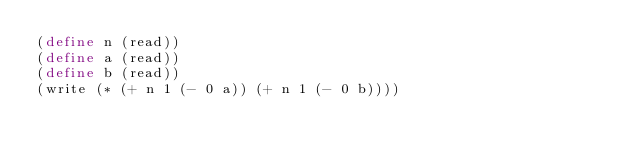Convert code to text. <code><loc_0><loc_0><loc_500><loc_500><_Scheme_>(define n (read))
(define a (read))
(define b (read))
(write (* (+ n 1 (- 0 a)) (+ n 1 (- 0 b))))
</code> 